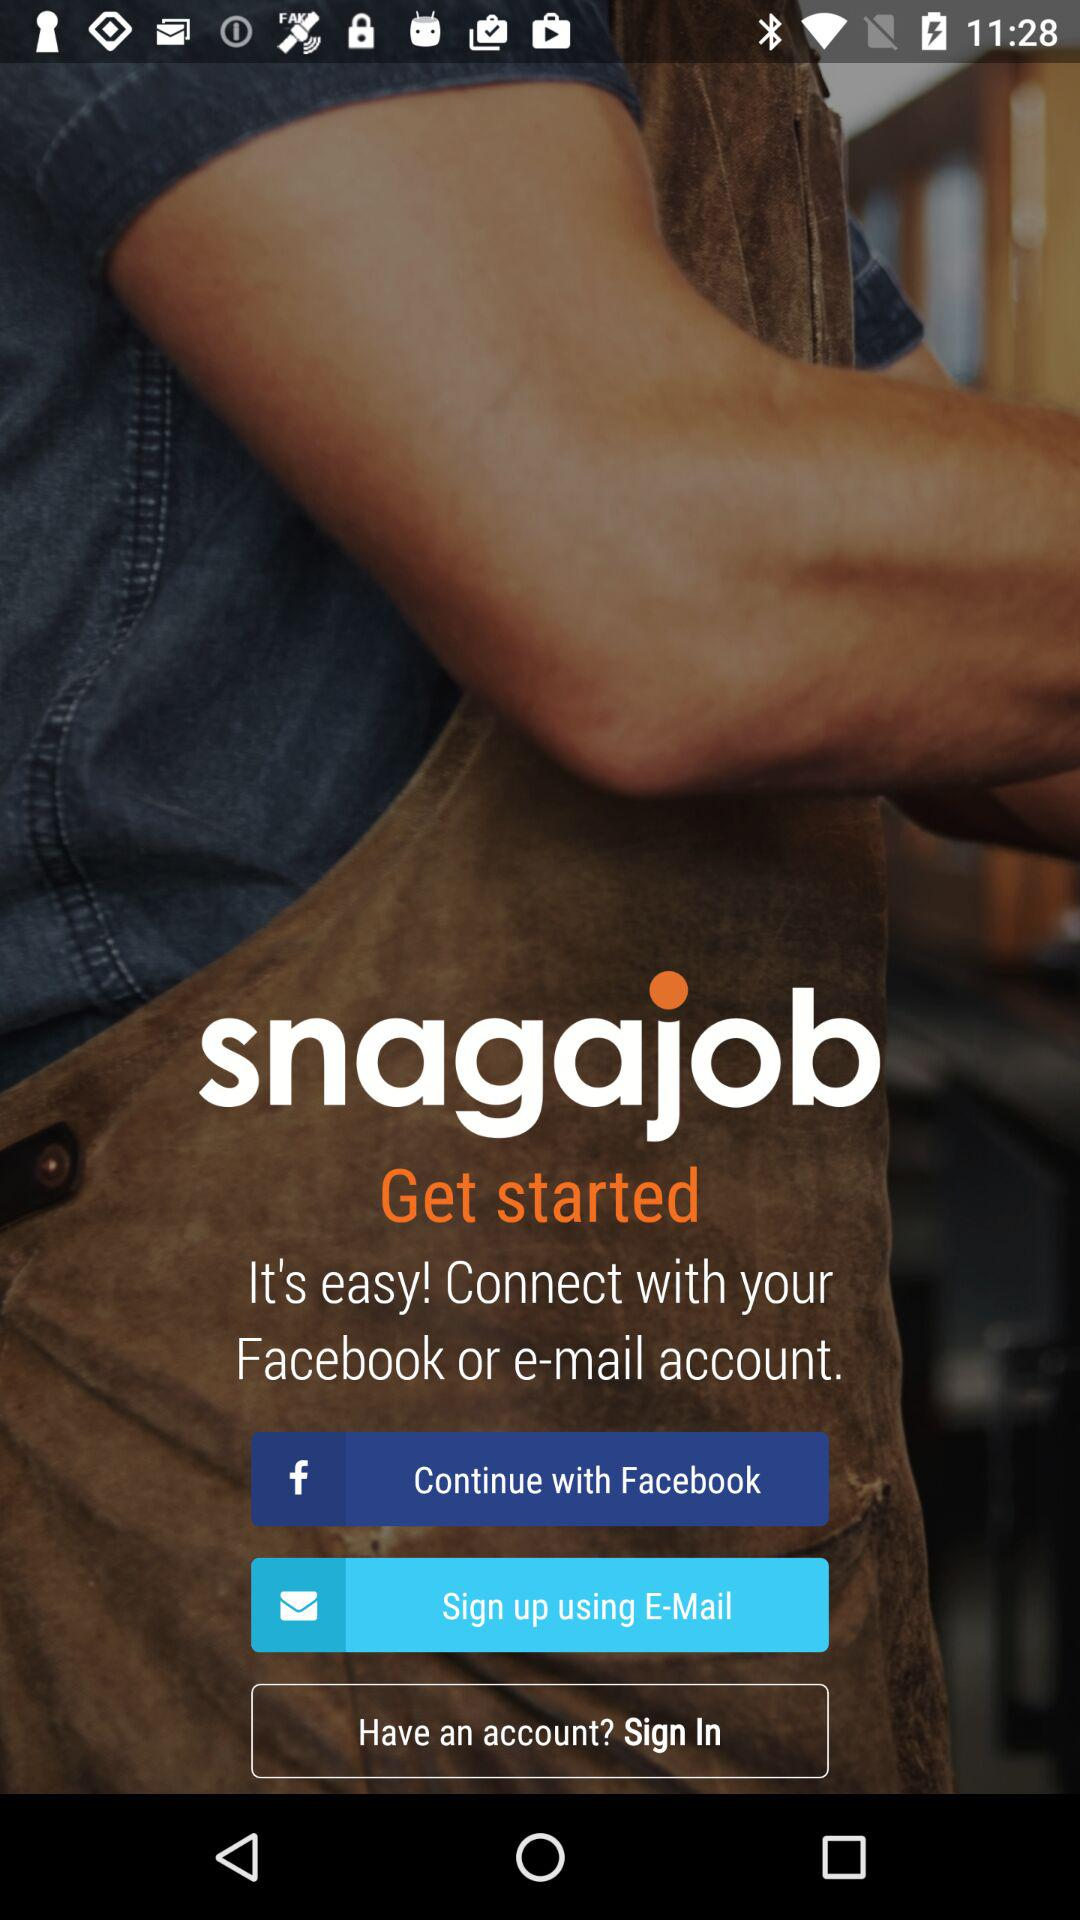How many sign up options does the user have?
Answer the question using a single word or phrase. 2 